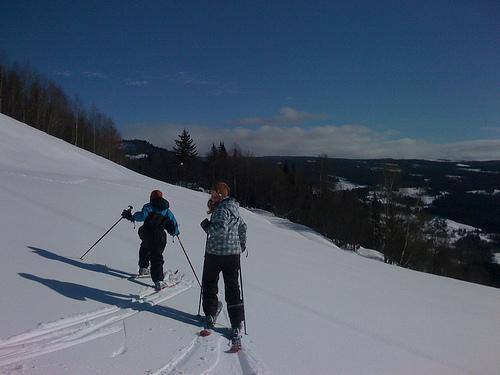Question: what is on the people's feet?
Choices:
A. Skis.
B. Boots.
C. Shoes.
D. Sneakers.
Answer with the letter. Answer: A Question: how many people are there?
Choices:
A. Three.
B. One.
C. Two.
D. Zero.
Answer with the letter. Answer: C Question: who is on the snow?
Choices:
A. Children.
B. People.
C. Skiers.
D. Boys.
Answer with the letter. Answer: C Question: where are the skiers?
Choices:
A. On a hill.
B. On a lift.
C. In the ski lodge.
D. On the mountain.
Answer with the letter. Answer: A Question: what are the people holding in their hands?
Choices:
A. Flowers.
B. Bags.
C. Food.
D. Poles.
Answer with the letter. Answer: D Question: what color is the snow?
Choices:
A. Grey.
B. Light grey.
C. Yellow.
D. White.
Answer with the letter. Answer: D 